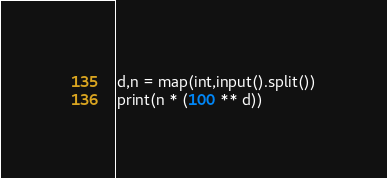<code> <loc_0><loc_0><loc_500><loc_500><_Python_>d,n = map(int,input().split())
print(n * (100 ** d))</code> 